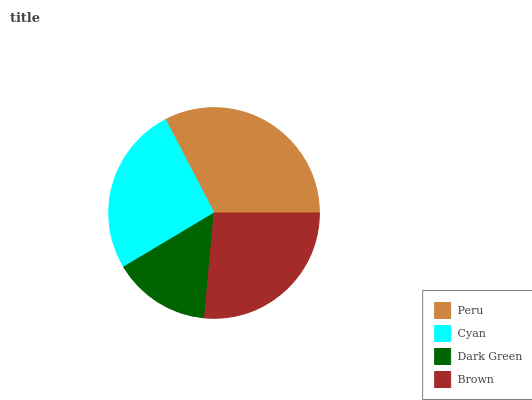Is Dark Green the minimum?
Answer yes or no. Yes. Is Peru the maximum?
Answer yes or no. Yes. Is Cyan the minimum?
Answer yes or no. No. Is Cyan the maximum?
Answer yes or no. No. Is Peru greater than Cyan?
Answer yes or no. Yes. Is Cyan less than Peru?
Answer yes or no. Yes. Is Cyan greater than Peru?
Answer yes or no. No. Is Peru less than Cyan?
Answer yes or no. No. Is Brown the high median?
Answer yes or no. Yes. Is Cyan the low median?
Answer yes or no. Yes. Is Cyan the high median?
Answer yes or no. No. Is Dark Green the low median?
Answer yes or no. No. 